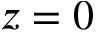Convert formula to latex. <formula><loc_0><loc_0><loc_500><loc_500>z = 0</formula> 